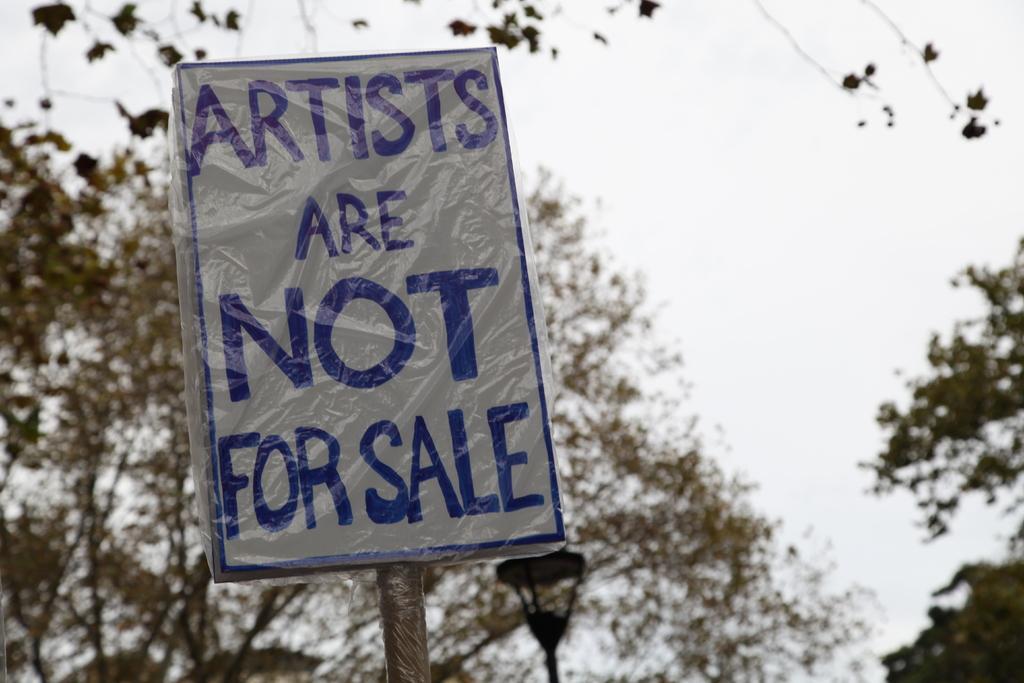Please provide a concise description of this image. In the center of the image we can see a board. In the background there are trees and sky. 